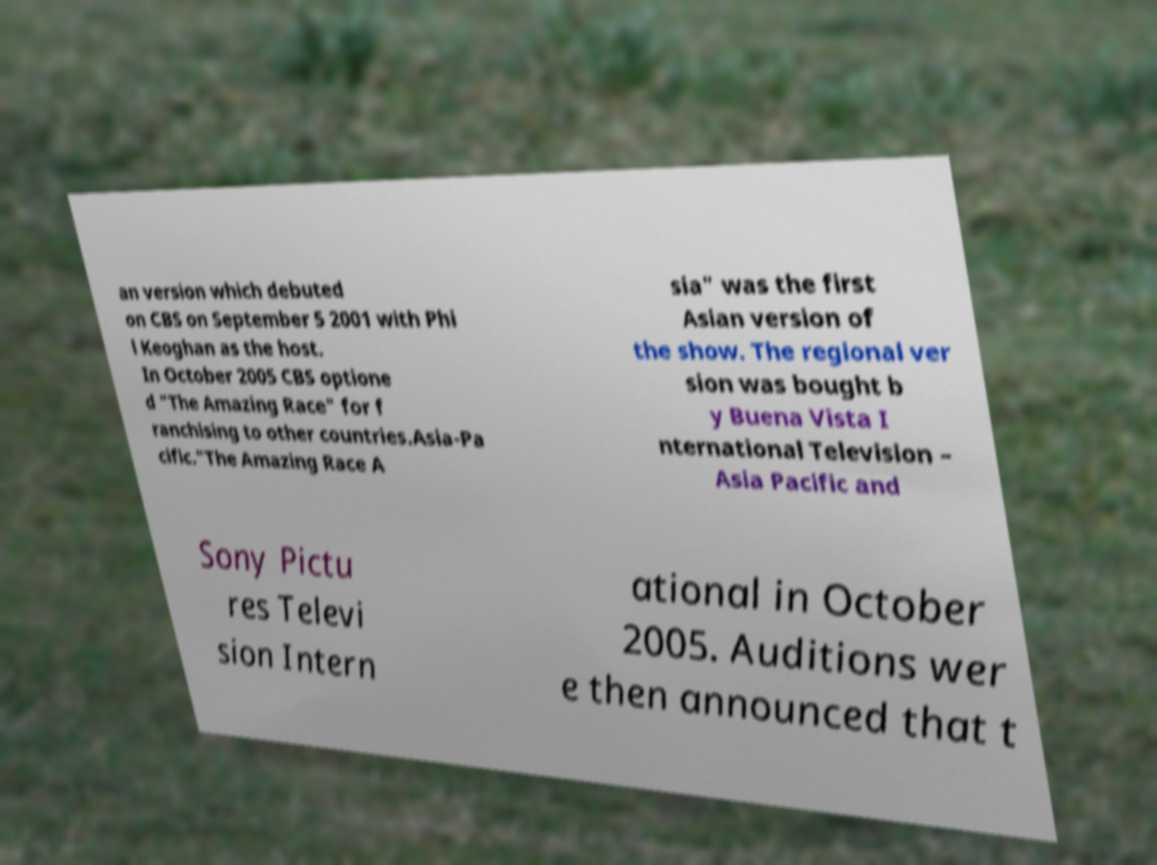Please read and relay the text visible in this image. What does it say? an version which debuted on CBS on September 5 2001 with Phi l Keoghan as the host. In October 2005 CBS optione d "The Amazing Race" for f ranchising to other countries.Asia-Pa cific."The Amazing Race A sia" was the first Asian version of the show. The regional ver sion was bought b y Buena Vista I nternational Television – Asia Pacific and Sony Pictu res Televi sion Intern ational in October 2005. Auditions wer e then announced that t 